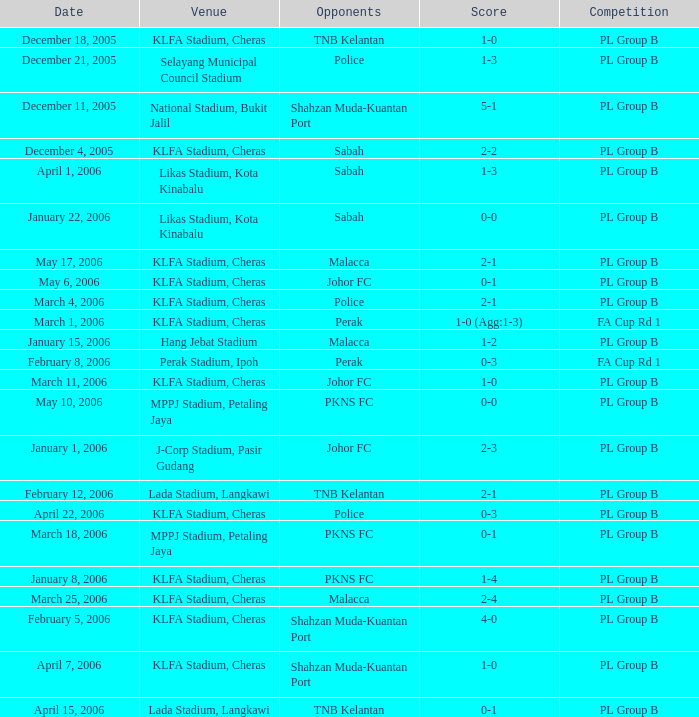In which match involving pkns fc's rivals was the result a 0-0 draw? PL Group B. 